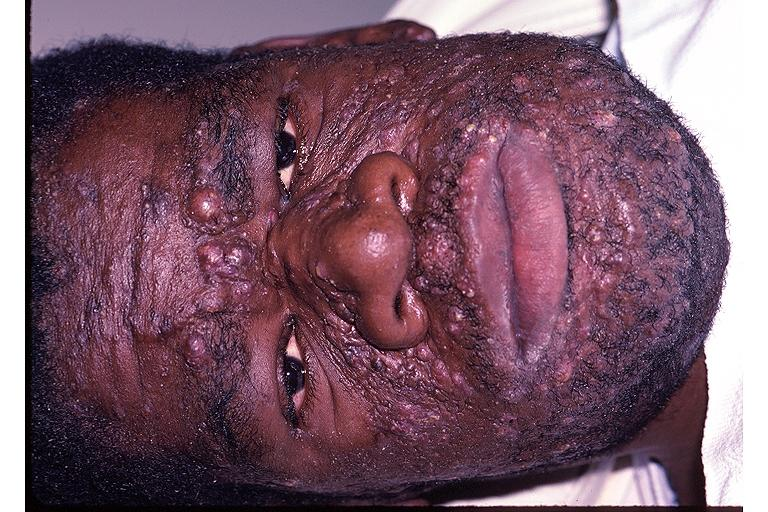where is this?
Answer the question using a single word or phrase. Skin 